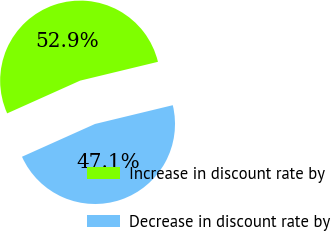<chart> <loc_0><loc_0><loc_500><loc_500><pie_chart><fcel>Increase in discount rate by<fcel>Decrease in discount rate by<nl><fcel>52.94%<fcel>47.06%<nl></chart> 